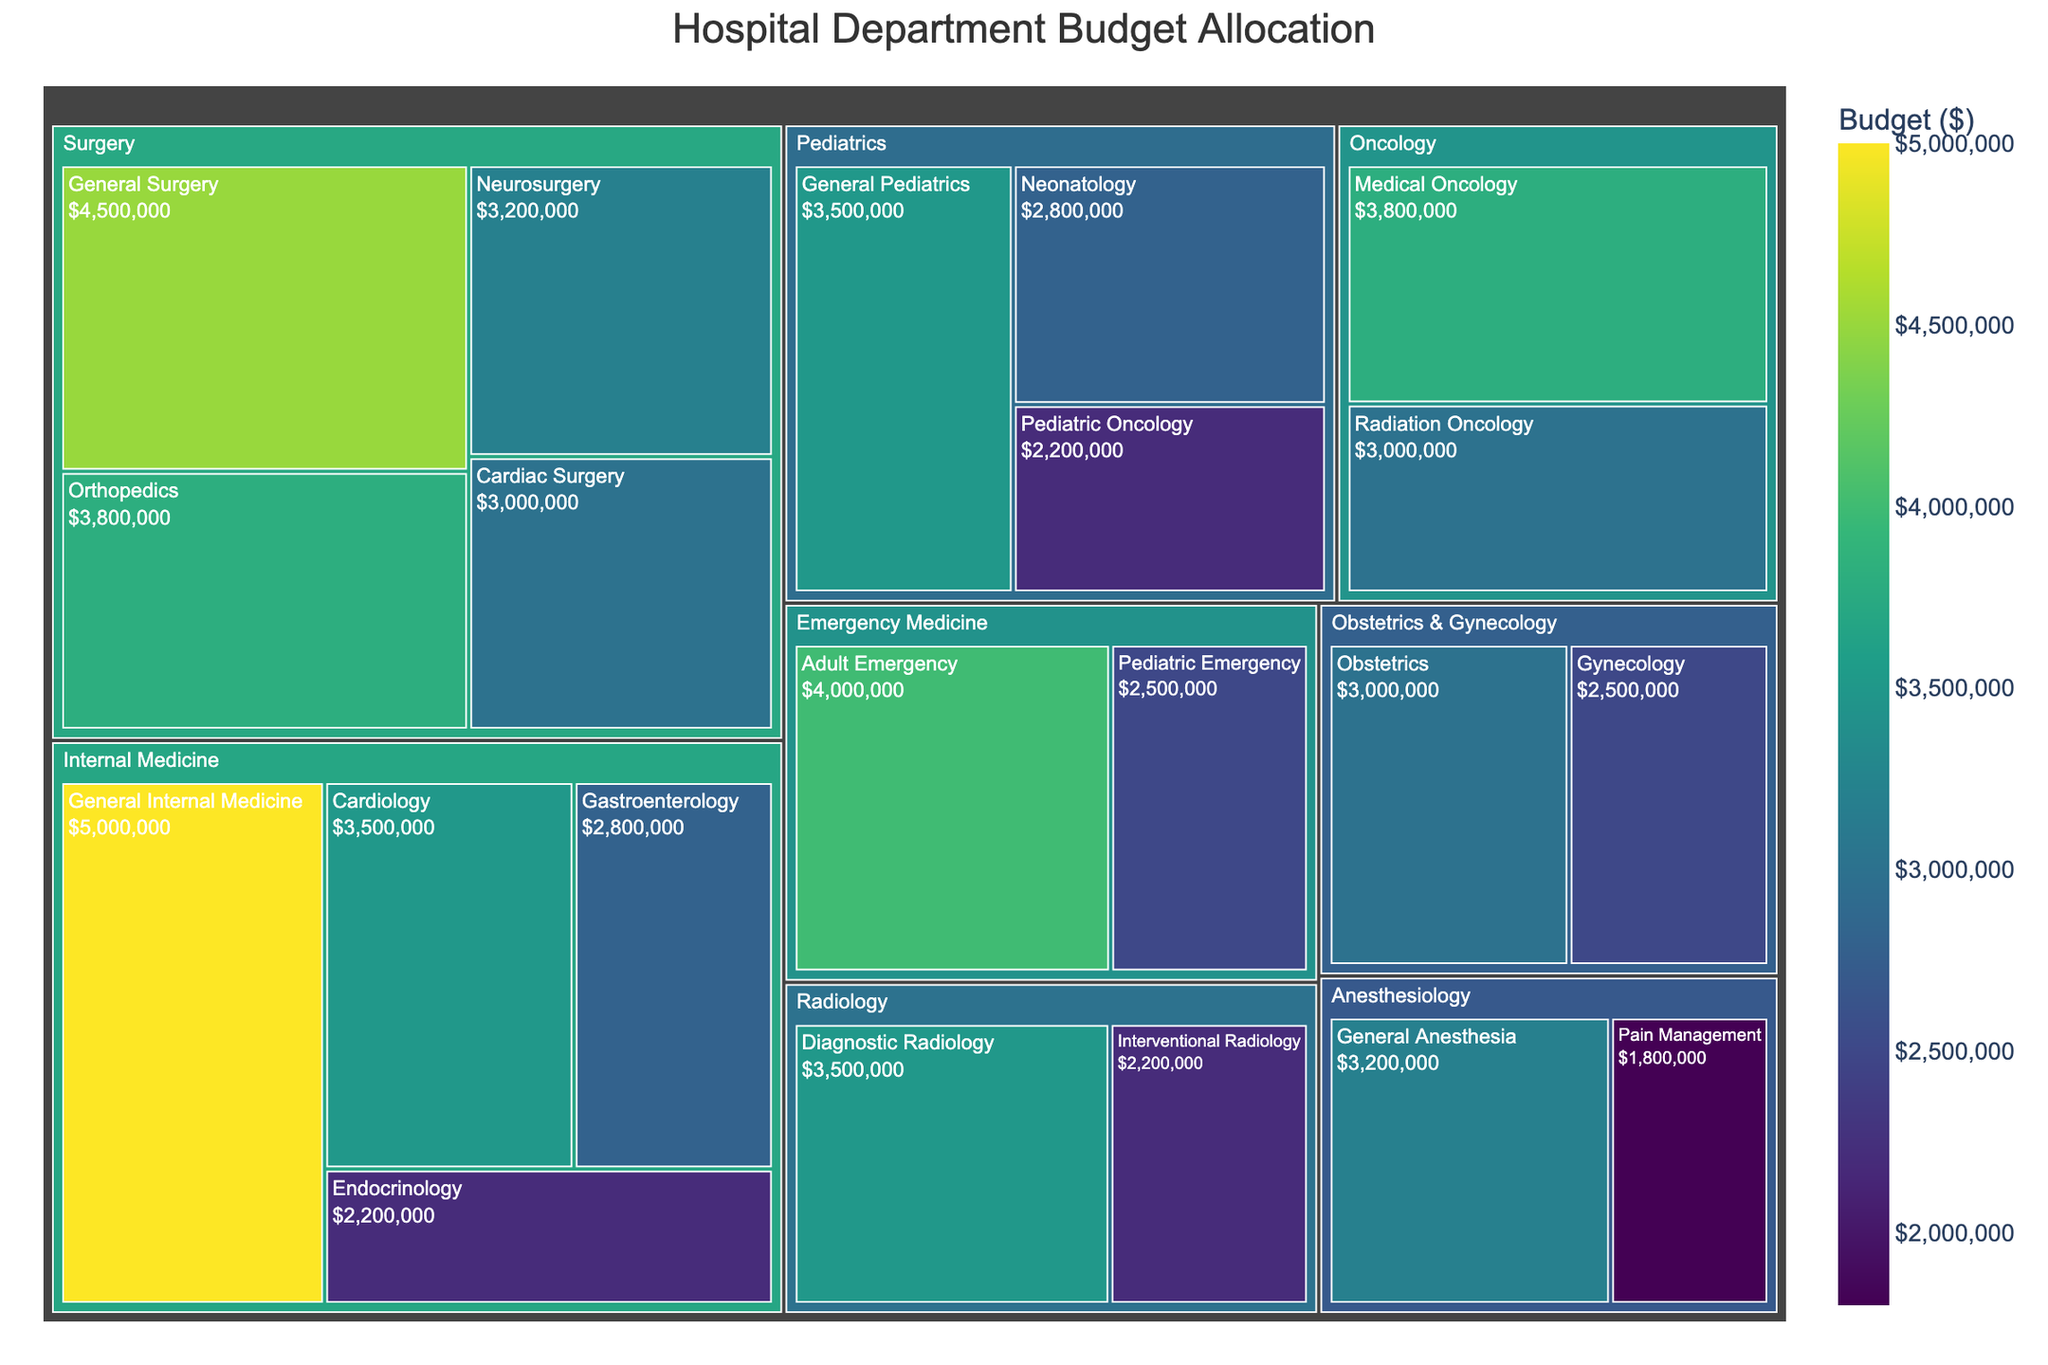What is the highest budget allocation among all specialties? Looking at the treemap, the specialty with the largest area and darkest color represents the highest budget allocation. General Internal Medicine has a budget of $5,000,000, which is the highest.
Answer: $5,000,000 Which department has the most categories listed under it? By counting the number of subdivisions under each department in the treemap, Internal Medicine and Surgery have the highest number of specialties listed, each with four categories.
Answer: Internal Medicine and Surgery What is the total budget allocation for the Pediatrics department? Summing up the budget allocations for General Pediatrics ($3,500,000), Neonatology ($2,800,000), and Pediatric Oncology ($2,200,000), we get a total of $3,500,000 + $2,800,000 + $2,200,000 = $8,500,000.
Answer: $8,500,000 Which specialty in the Surgery department has the least budget allocation? Comparing the areas and colors of the specialties under Surgery, Cardiac Surgery has the least budget allocation of $3,000,000.
Answer: Cardiac Surgery How does the budget for General Pediatrics compare to General Surgery? General Pediatrics has a budget of $3,500,000, while General Surgery has a budget of $4,500,000. General Surgery thus has a higher budget.
Answer: General Surgery has a higher budget What is the combined budget of all the specialties under Anesthesiology? Summing the budgets of General Anesthesia ($3,200,000) and Pain Management ($1,800,000), we get a total of $3,200,000 + $1,800,000 = $5,000,000.
Answer: $5,000,000 Which department occupies the smallest area on the treemap? Observing the sizes of the areas representing each department, Anesthesiology has the smallest total area, indicating the smallest budget allocation.
Answer: Anesthesiology If the budgets for Cardiology and Gastroenterology were combined, how would it compare to the budget for Emergency Medicine? The combined budget for Cardiology ($3,500,000) and Gastroenterology ($2,800,000) is $3,500,000 + $2,800,000 = $6,300,000. The total budget for Emergency Medicine including Adult Emergency ($4,000,000) and Pediatric Emergency ($2,500,000) is $4,000,000 + $2,500,000 = $6,500,000. As a result, Emergency Medicine has a higher budget.
Answer: Emergency Medicine has a higher budget Which specialty in Oncology has the larger budget? Comparing the areas and colors of Medical Oncology and Radiation Oncology in the treemap, Medical Oncology has the larger budget of $3,800,000.
Answer: Medical Oncology 